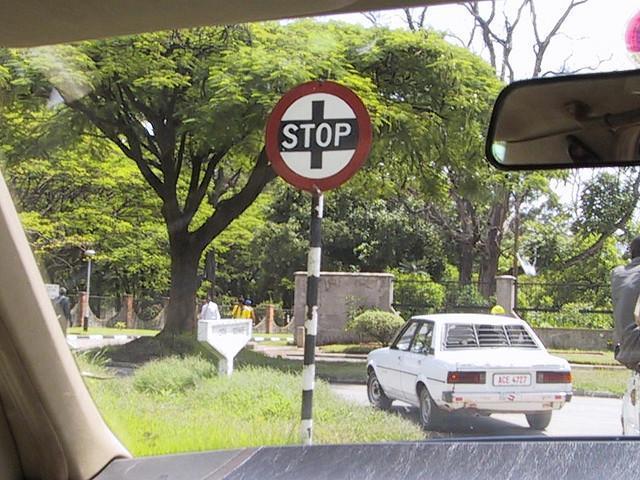How many brake lights does the car have?
Give a very brief answer. 2. 